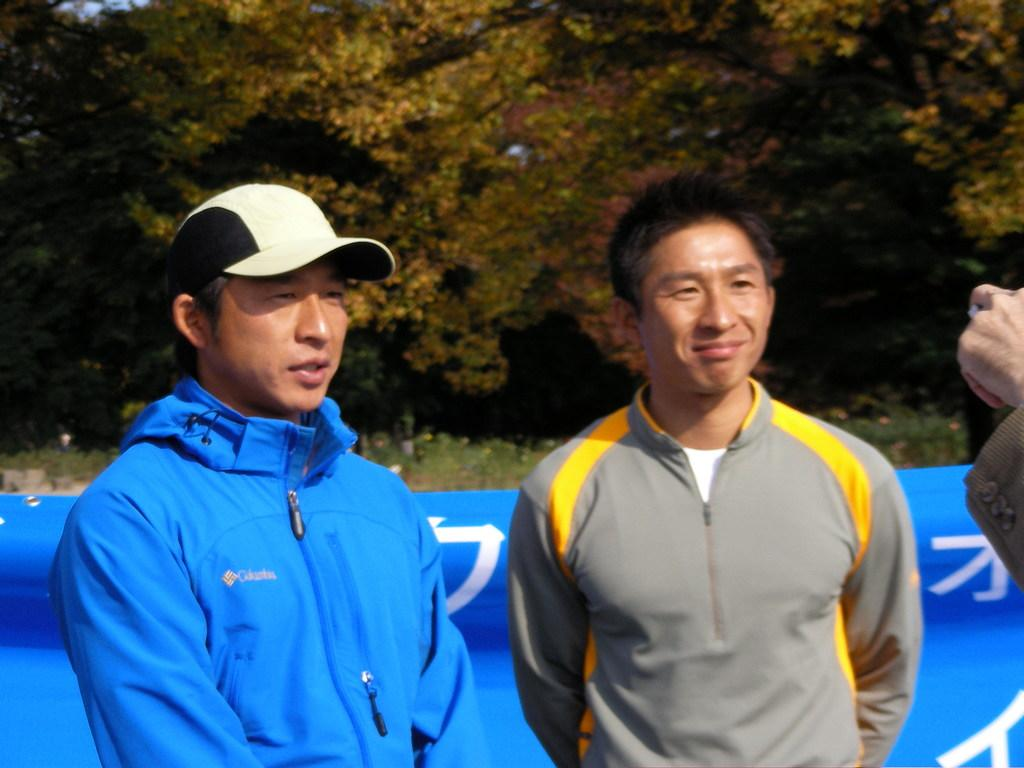What is happening in the image involving the people? There are people standing in the image, but their specific activity is not clear. What can be seen behind the people in the image? There is a banner visible behind the people. What type of natural environment is visible in the background of the image? There is grass and trees in the background of the image. What type of stitch is being used by the woman in the image? There is no woman present in the image, and no stitching activity is visible. 